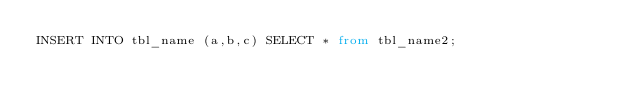<code> <loc_0><loc_0><loc_500><loc_500><_SQL_>INSERT INTO tbl_name (a,b,c) SELECT * from tbl_name2;</code> 